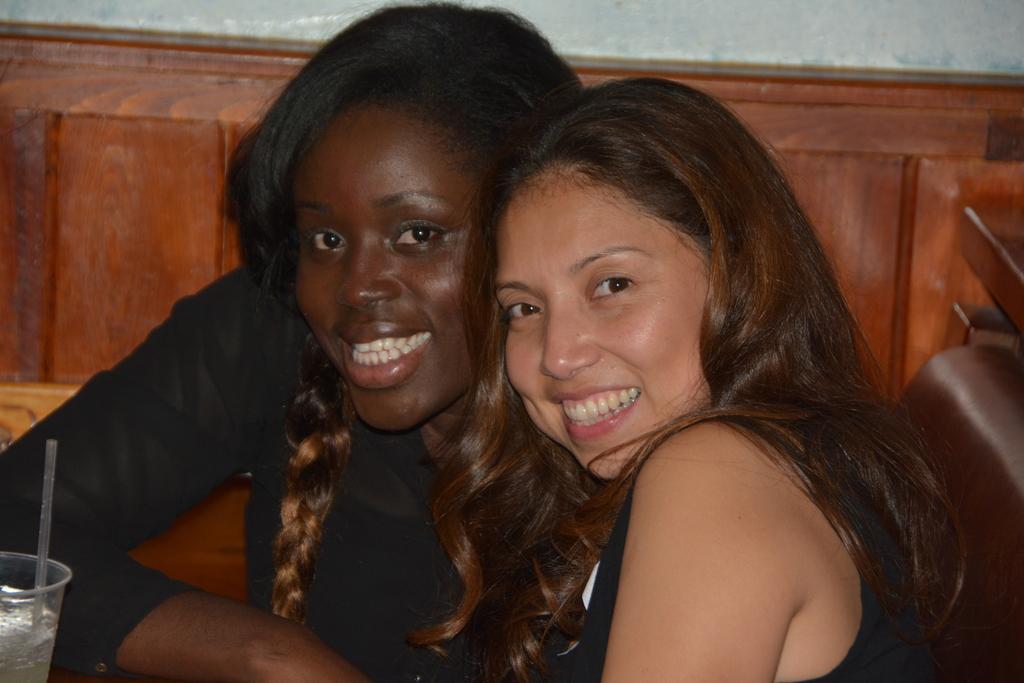Describe this image in one or two sentences. In this image we can see two women. One woman is wearing black dress. To the left side of the image we can see a glass with a straw in it. 